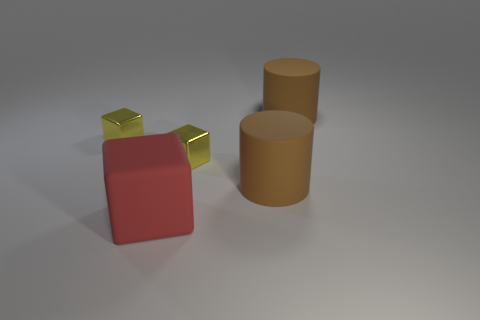Add 3 cylinders. How many objects exist? 8 Subtract all cubes. How many objects are left? 2 Subtract 0 gray balls. How many objects are left? 5 Subtract all small brown matte objects. Subtract all big red rubber blocks. How many objects are left? 4 Add 4 tiny yellow things. How many tiny yellow things are left? 6 Add 2 cubes. How many cubes exist? 5 